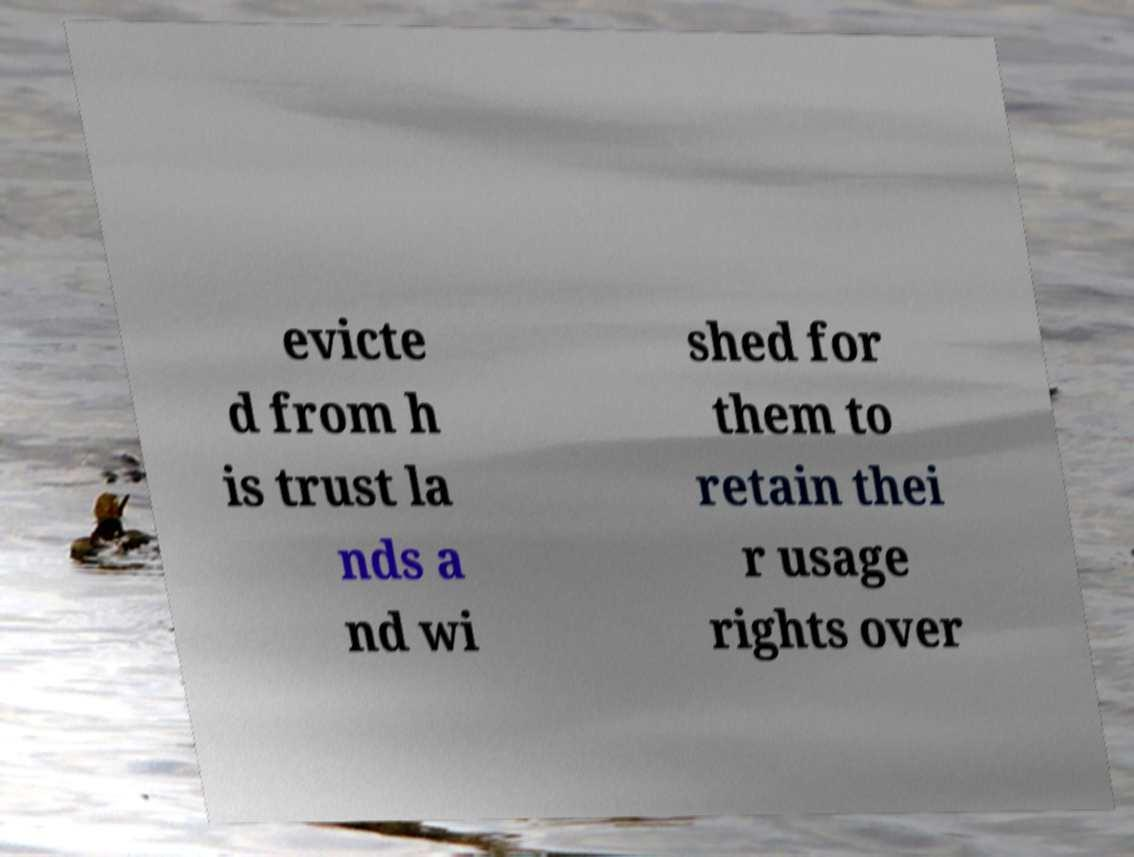For documentation purposes, I need the text within this image transcribed. Could you provide that? evicte d from h is trust la nds a nd wi shed for them to retain thei r usage rights over 